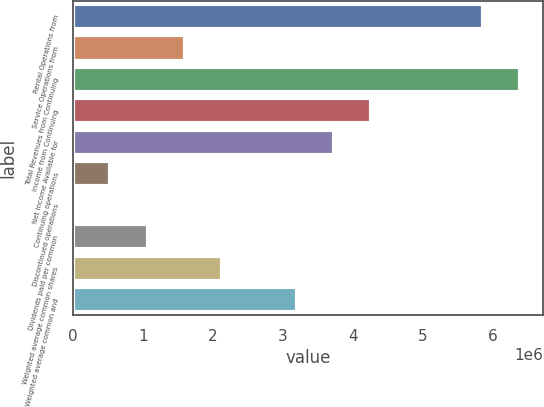Convert chart to OTSL. <chart><loc_0><loc_0><loc_500><loc_500><bar_chart><fcel>Rental Operations from<fcel>Service Operations from<fcel>Total Revenues from Continuing<fcel>Income from Continuing<fcel>Net Income Available for<fcel>Continuing operations<fcel>Discontinued operations<fcel>Dividends paid per common<fcel>Weighted average common shares<fcel>Weighted average common and<nl><fcel>5.86304e+06<fcel>1.59901e+06<fcel>6.39604e+06<fcel>4.26403e+06<fcel>3.73102e+06<fcel>533003<fcel>0.1<fcel>1.06601e+06<fcel>2.13201e+06<fcel>3.19802e+06<nl></chart> 